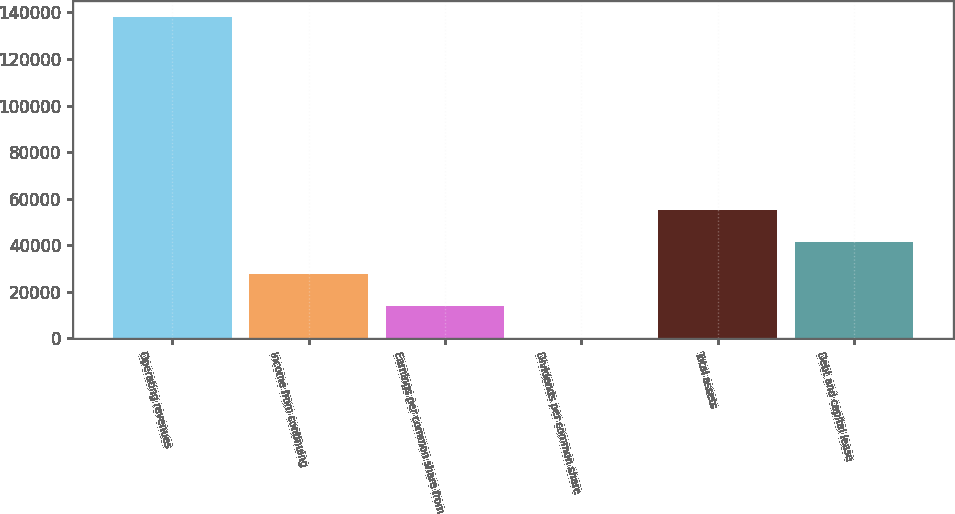Convert chart to OTSL. <chart><loc_0><loc_0><loc_500><loc_500><bar_chart><fcel>Operating revenues<fcel>Income from continuing<fcel>Earnings per common share from<fcel>Dividends per common share<fcel>Total assets<fcel>Debt and capital lease<nl><fcel>138074<fcel>27615.5<fcel>13808.2<fcel>0.85<fcel>55230.1<fcel>41422.8<nl></chart> 